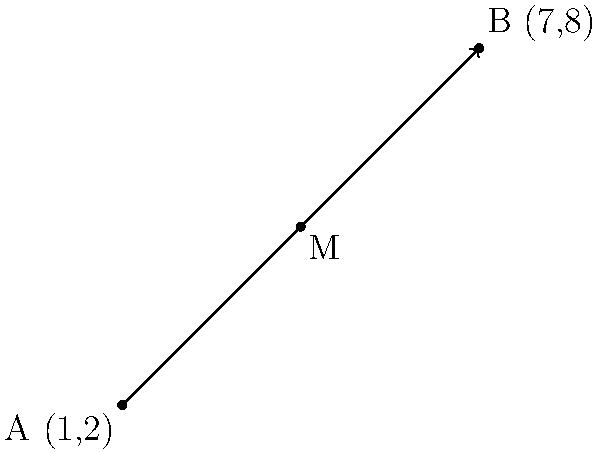Two surveillance points are located at coordinates (1,2) and (7,8) in your territory. To optimize coverage, you need to place a signal booster at the midpoint of these two locations. Calculate the coordinates of this midpoint. To find the midpoint of a line segment connecting two points, we use the midpoint formula:

$$ M_x = \frac{x_1 + x_2}{2}, \quad M_y = \frac{y_1 + y_2}{2} $$

Where $(x_1, y_1)$ and $(x_2, y_2)$ are the coordinates of the two endpoints.

Given:
Point A (Surveillance Point 1): $(1, 2)$
Point B (Surveillance Point 2): $(7, 8)$

Step 1: Calculate the x-coordinate of the midpoint
$$ M_x = \frac{1 + 7}{2} = \frac{8}{2} = 4 $$

Step 2: Calculate the y-coordinate of the midpoint
$$ M_y = \frac{2 + 8}{2} = \frac{10}{2} = 5 $$

Therefore, the midpoint M has coordinates (4, 5).
Answer: (4, 5) 